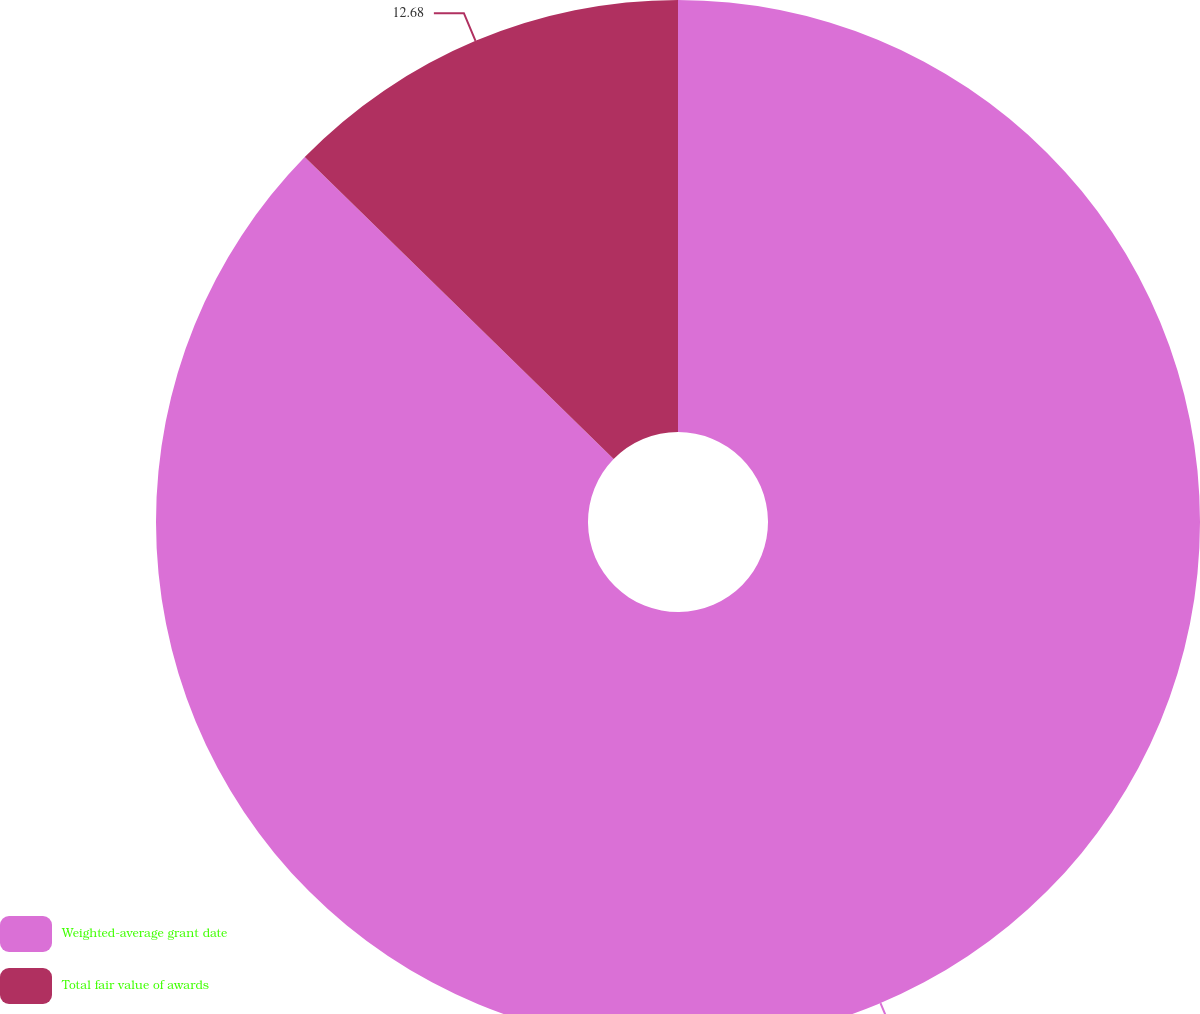<chart> <loc_0><loc_0><loc_500><loc_500><pie_chart><fcel>Weighted-average grant date<fcel>Total fair value of awards<nl><fcel>87.32%<fcel>12.68%<nl></chart> 